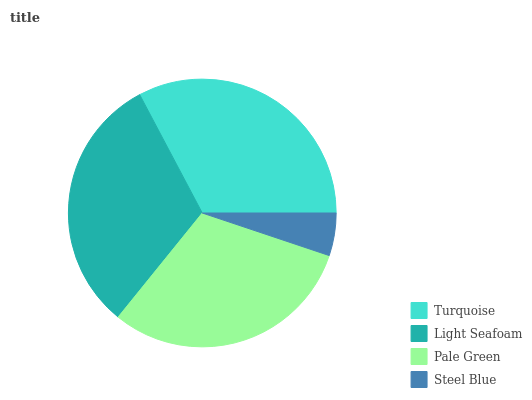Is Steel Blue the minimum?
Answer yes or no. Yes. Is Turquoise the maximum?
Answer yes or no. Yes. Is Light Seafoam the minimum?
Answer yes or no. No. Is Light Seafoam the maximum?
Answer yes or no. No. Is Turquoise greater than Light Seafoam?
Answer yes or no. Yes. Is Light Seafoam less than Turquoise?
Answer yes or no. Yes. Is Light Seafoam greater than Turquoise?
Answer yes or no. No. Is Turquoise less than Light Seafoam?
Answer yes or no. No. Is Light Seafoam the high median?
Answer yes or no. Yes. Is Pale Green the low median?
Answer yes or no. Yes. Is Turquoise the high median?
Answer yes or no. No. Is Turquoise the low median?
Answer yes or no. No. 